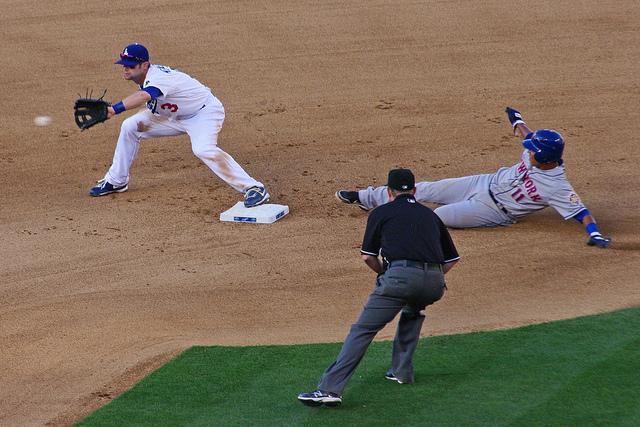If he hits it where is he going to run to?
Write a very short answer. Base. What is the man in white called within the game?
Concise answer only. Baseman. Did one of the players fall?
Give a very brief answer. Yes. What sport is being played?
Be succinct. Baseball. Who is holding a glove?
Keep it brief. 2nd baseman. What team went for a run?
Answer briefly. New york. Is this a professional game?
Keep it brief. Yes. What color is the glove?
Write a very short answer. Black. What state is the team on the right from?
Give a very brief answer. New york. 